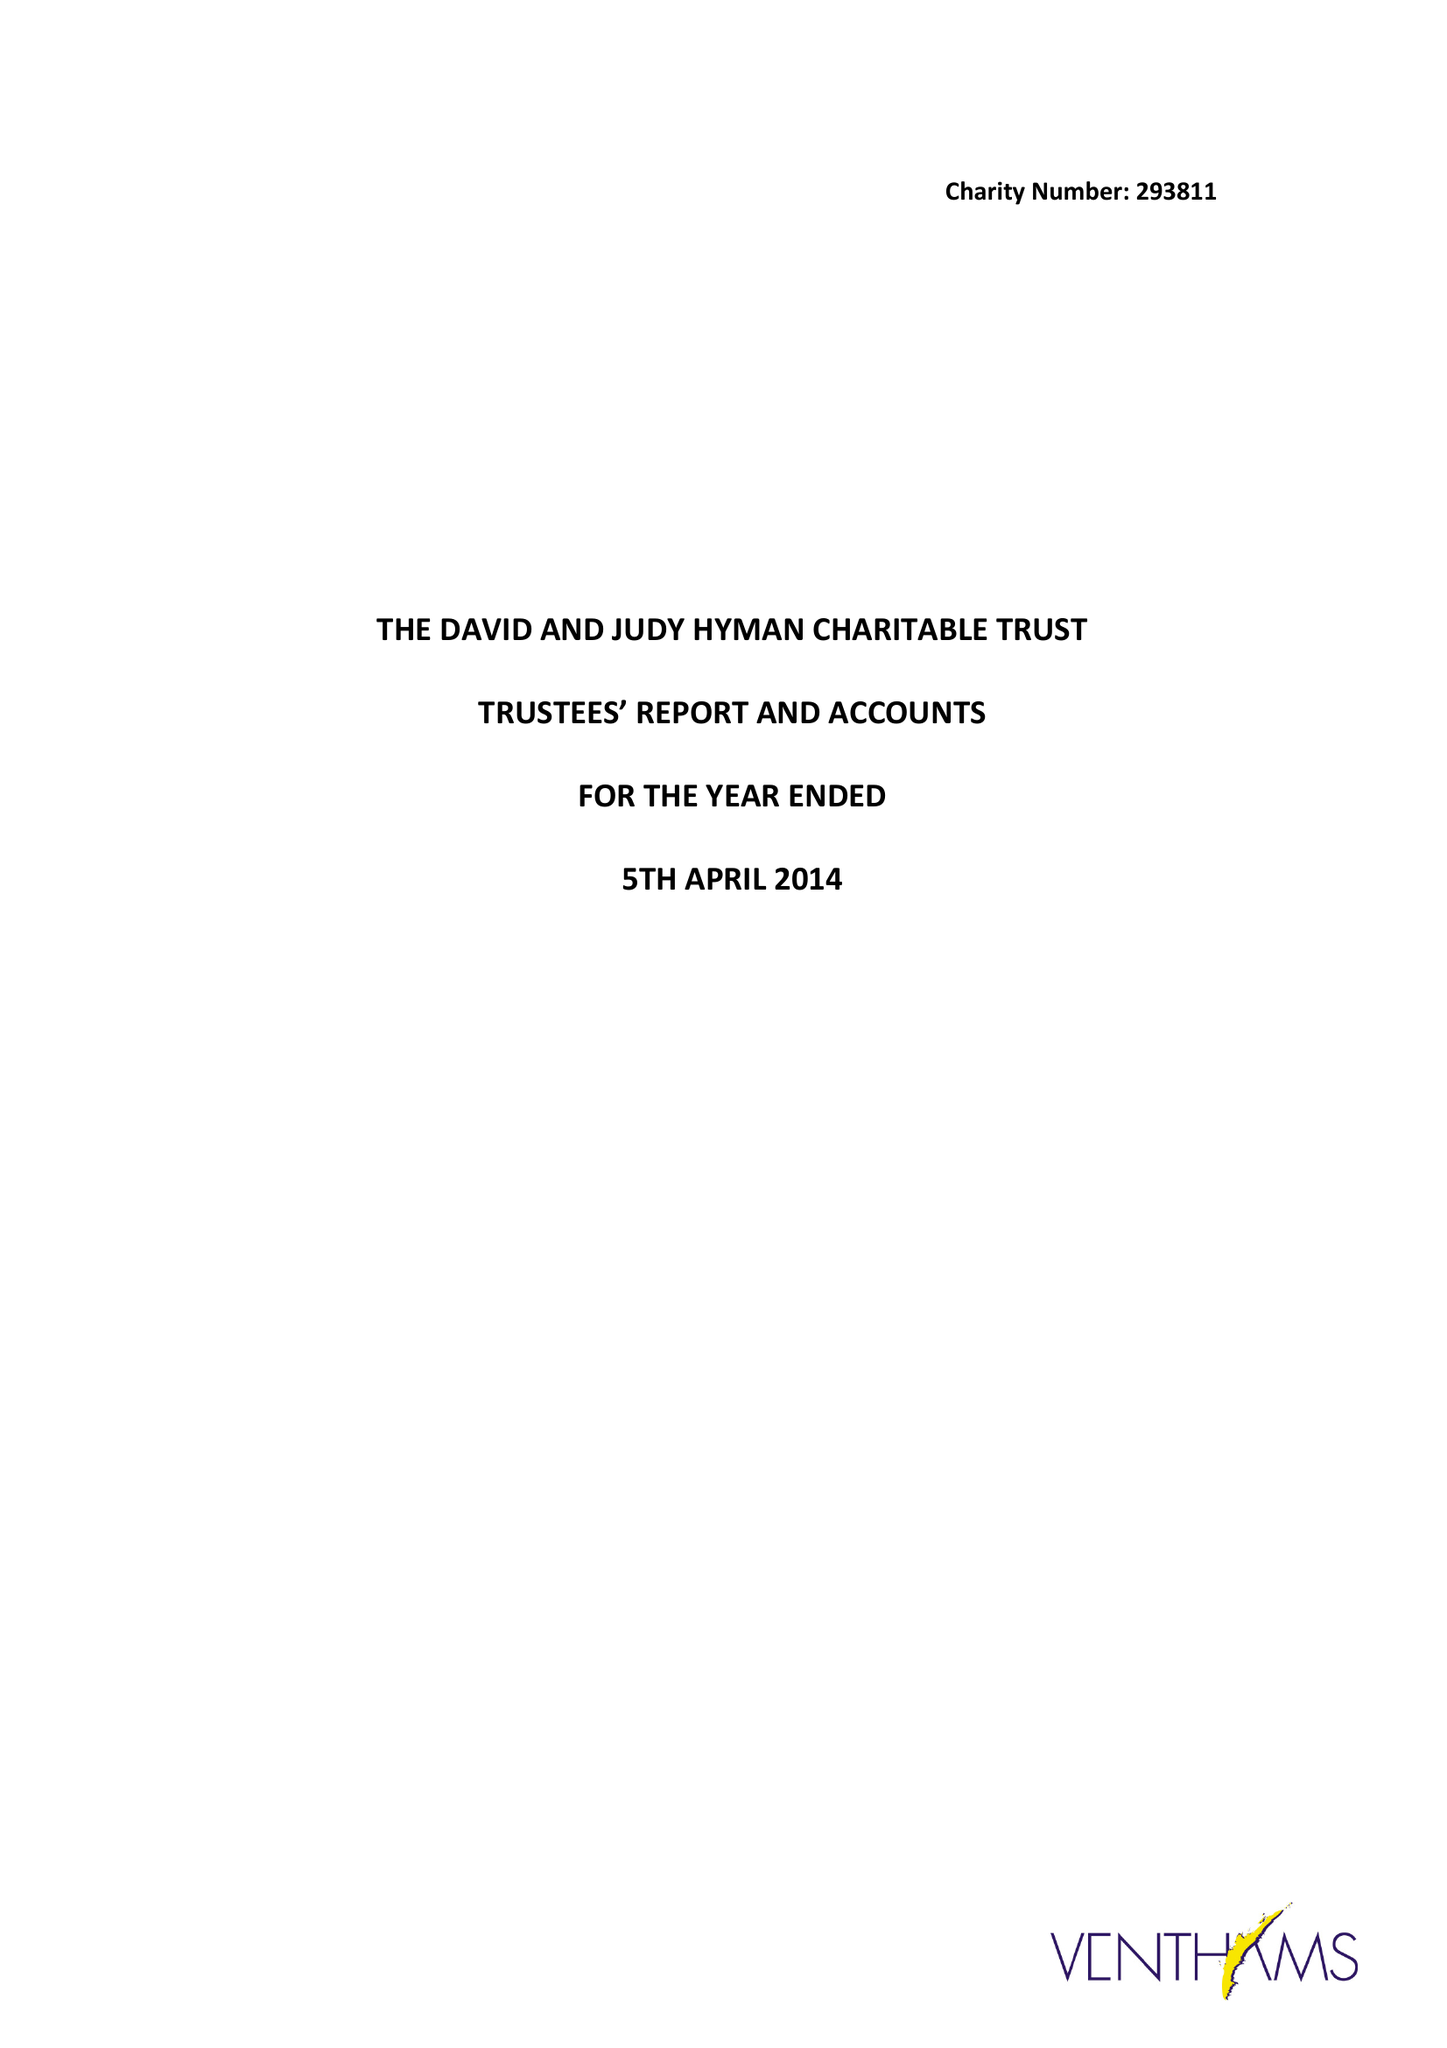What is the value for the income_annually_in_british_pounds?
Answer the question using a single word or phrase. 25630.00 